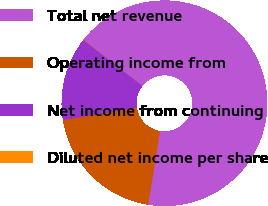Convert chart to OTSL. <chart><loc_0><loc_0><loc_500><loc_500><pie_chart><fcel>Total net revenue<fcel>Operating income from<fcel>Net income from continuing<fcel>Diluted net income per share<nl><fcel>66.88%<fcel>19.88%<fcel>13.2%<fcel>0.04%<nl></chart> 